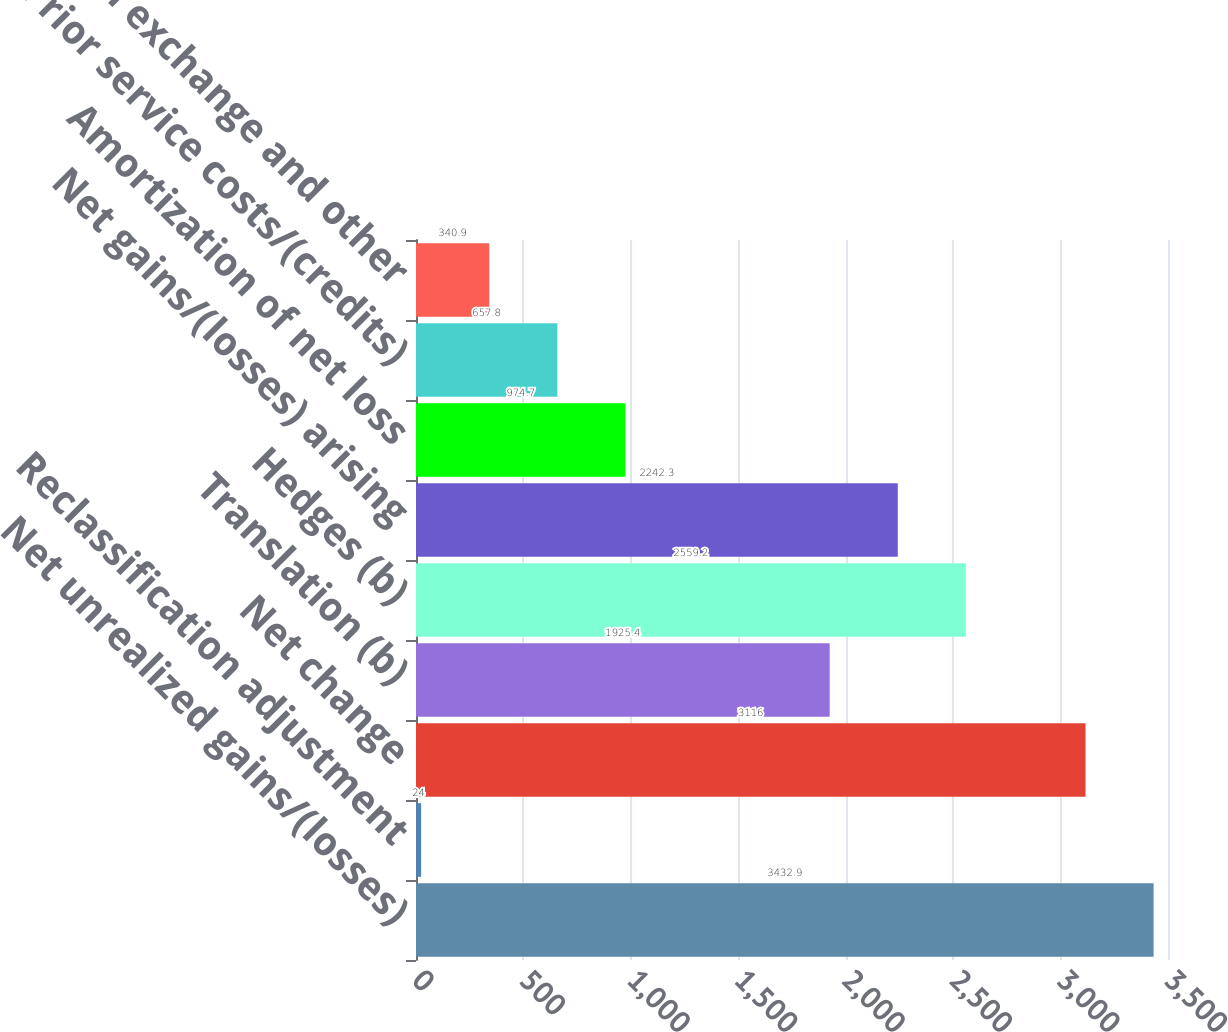<chart> <loc_0><loc_0><loc_500><loc_500><bar_chart><fcel>Net unrealized gains/(losses)<fcel>Reclassification adjustment<fcel>Net change<fcel>Translation (b)<fcel>Hedges (b)<fcel>Net gains/(losses) arising<fcel>Amortization of net loss<fcel>Prior service costs/(credits)<fcel>Foreign exchange and other<nl><fcel>3432.9<fcel>24<fcel>3116<fcel>1925.4<fcel>2559.2<fcel>2242.3<fcel>974.7<fcel>657.8<fcel>340.9<nl></chart> 